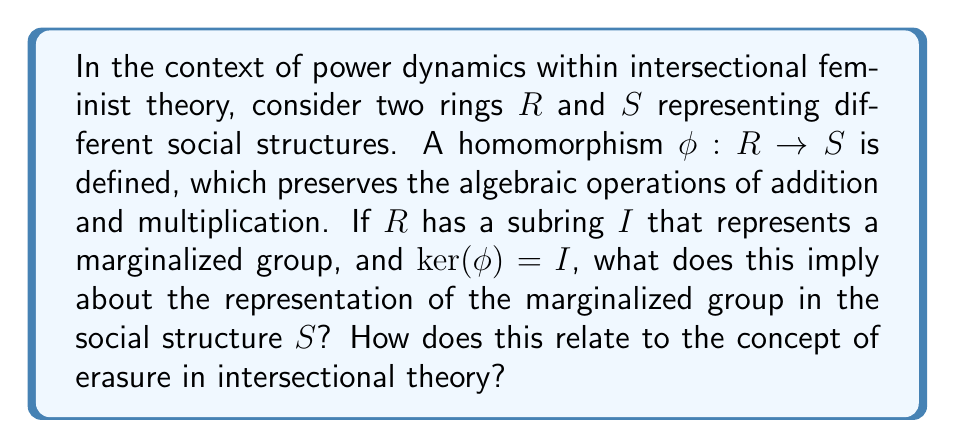Show me your answer to this math problem. To understand this question, we need to break it down into its mathematical and sociological components:

1. Mathematical context:
   - We have two rings, $R$ and $S$, representing different social structures.
   - A homomorphism $\phi: R \rightarrow S$ is defined between these rings.
   - $R$ has a subring $I$ representing a marginalized group.
   - The kernel of $\phi$, denoted as $\ker(\phi)$, is equal to $I$.

2. Ring homomorphism properties:
   - A ring homomorphism preserves the operations of addition and multiplication.
   - The kernel of a homomorphism is the set of elements that map to the zero element in the codomain.

3. First Isomorphism Theorem:
   The First Isomorphism Theorem states that for a ring homomorphism $\phi: R \rightarrow S$:
   
   $$R/\ker(\phi) \cong \text{Im}(\phi)$$

   Where $R/\ker(\phi)$ is the quotient ring and $\text{Im}(\phi)$ is the image of $\phi$ in $S$.

4. Interpretation in the context of power dynamics:
   - The kernel being equal to the subring $I$ means that all elements of $I$ are mapped to zero in $S$.
   - In the context of social structures, this implies that the characteristics or identities represented by $I$ (the marginalized group) are not directly represented in the structure $S$.
   - The isomorphism $R/I \cong \text{Im}(\phi)$ suggests that the image of $\phi$ in $S$ represents the quotient structure where the marginalized group's identities are "factored out" or erased.

5. Relation to erasure in intersectional theory:
   - Erasure refers to the overlooking or dismissal of certain identities or experiences in discussions or representations of marginalized groups.
   - The mathematical structure here provides an analogy for how certain identities can be systematically removed or made invisible in the transition from one social structure to another.
   - The homomorphism $\phi$ represents a transformation of social structures that fails to carry forward the representation of the marginalized group $I$.

This mathematical model provides a formal way to understand how power dynamics can lead to the erasure of certain groups in societal transformations or representations.
Answer: The condition $\ker(\phi) = I$ implies that the marginalized group represented by subring $I$ is mapped to zero in the social structure $S$, effectively erasing their distinct representation. This mathematically models the concept of erasure in intersectional theory, where certain identities or experiences are systematically overlooked or dismissed in the transformation or representation of social structures. 